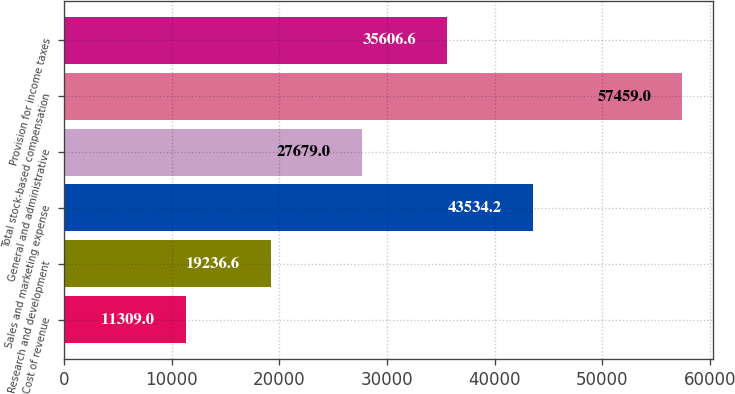Convert chart. <chart><loc_0><loc_0><loc_500><loc_500><bar_chart><fcel>Cost of revenue<fcel>Research and development<fcel>Sales and marketing expense<fcel>General and administrative<fcel>Total stock-based compensation<fcel>Provision for income taxes<nl><fcel>11309<fcel>19236.6<fcel>43534.2<fcel>27679<fcel>57459<fcel>35606.6<nl></chart> 